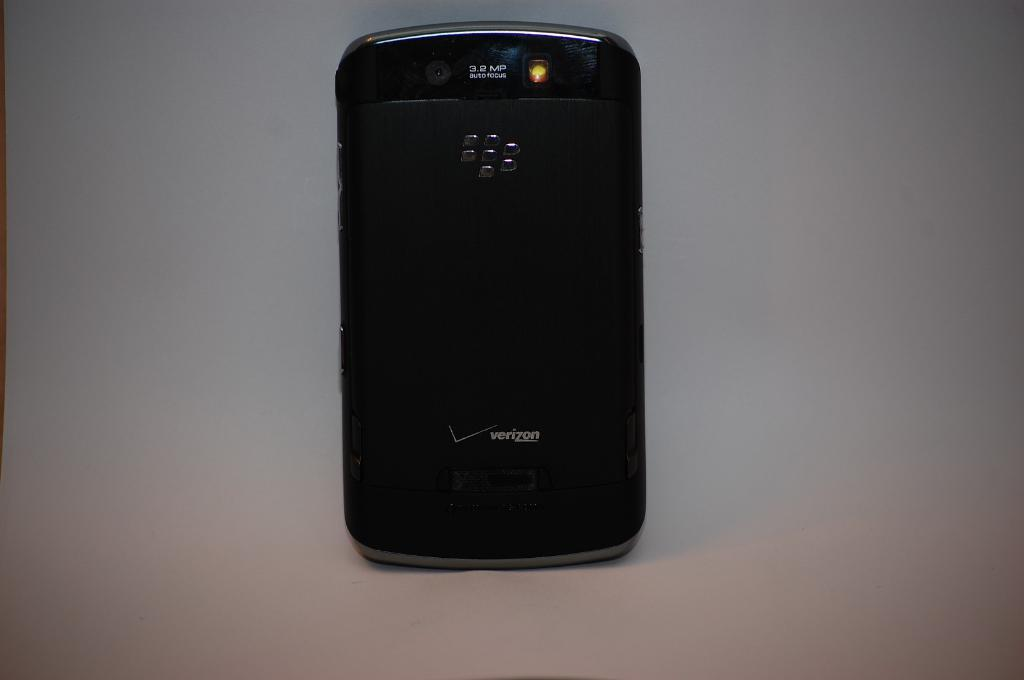<image>
Summarize the visual content of the image. A black Verizon Cell Phone sits on the face of the phone with a logo being displayed on the back. 